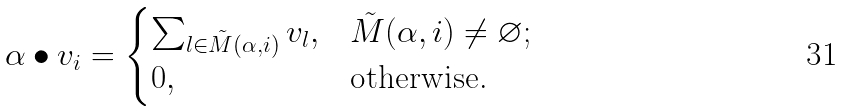Convert formula to latex. <formula><loc_0><loc_0><loc_500><loc_500>\alpha \bullet v _ { i } = \begin{cases} \sum _ { l \in \tilde { M } ( \alpha , i ) } v _ { l } , & \tilde { M } ( \alpha , i ) \neq \varnothing ; \\ 0 , & \text {otherwise.} \end{cases}</formula> 